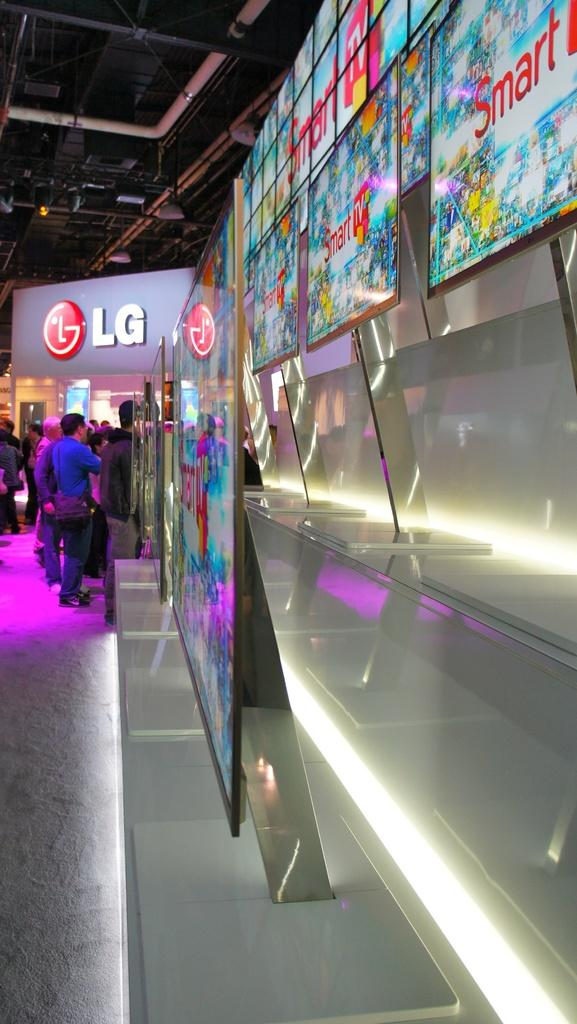What is the main subject of the image? There is a group of people standing in the image. What electronic devices can be seen in the image? There are televisions in the image. What type of illumination is present in the image? There is a light in the image. What part of a building is visible in the image? The roof is visible in the image. Can you tell me how many thumbs are visible in the image? There is no mention of thumbs or any body parts in the provided facts, so it is impossible to determine the number of thumbs visible in the image. 